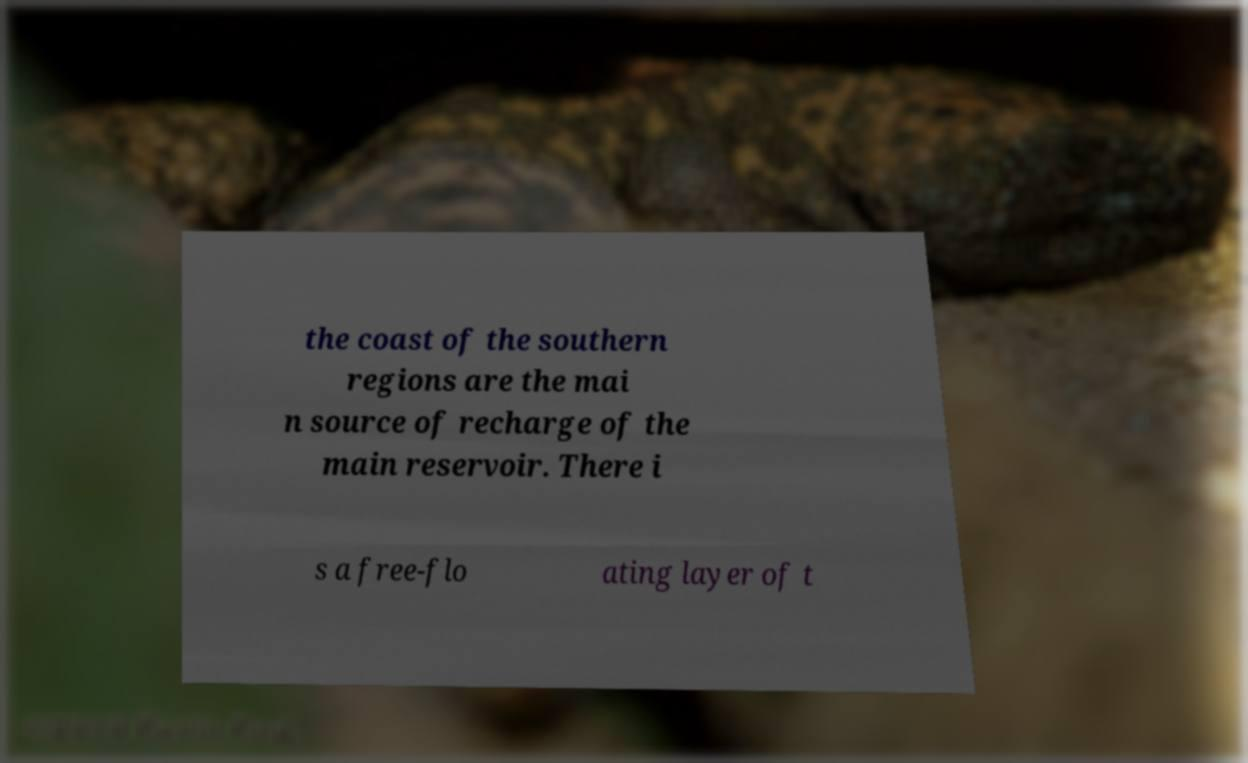For documentation purposes, I need the text within this image transcribed. Could you provide that? the coast of the southern regions are the mai n source of recharge of the main reservoir. There i s a free-flo ating layer of t 